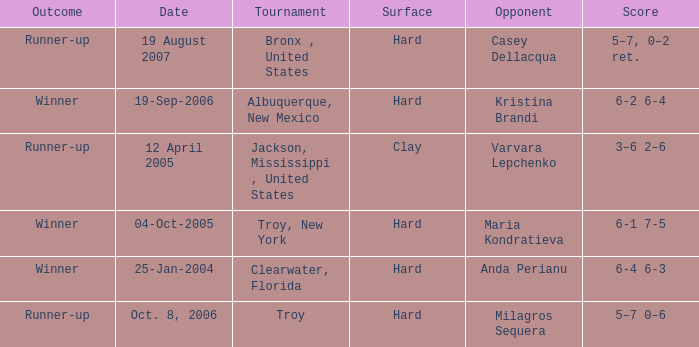What was the outcome of the game played on 19-Sep-2006? Winner. 